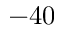Convert formula to latex. <formula><loc_0><loc_0><loc_500><loc_500>- 4 0</formula> 